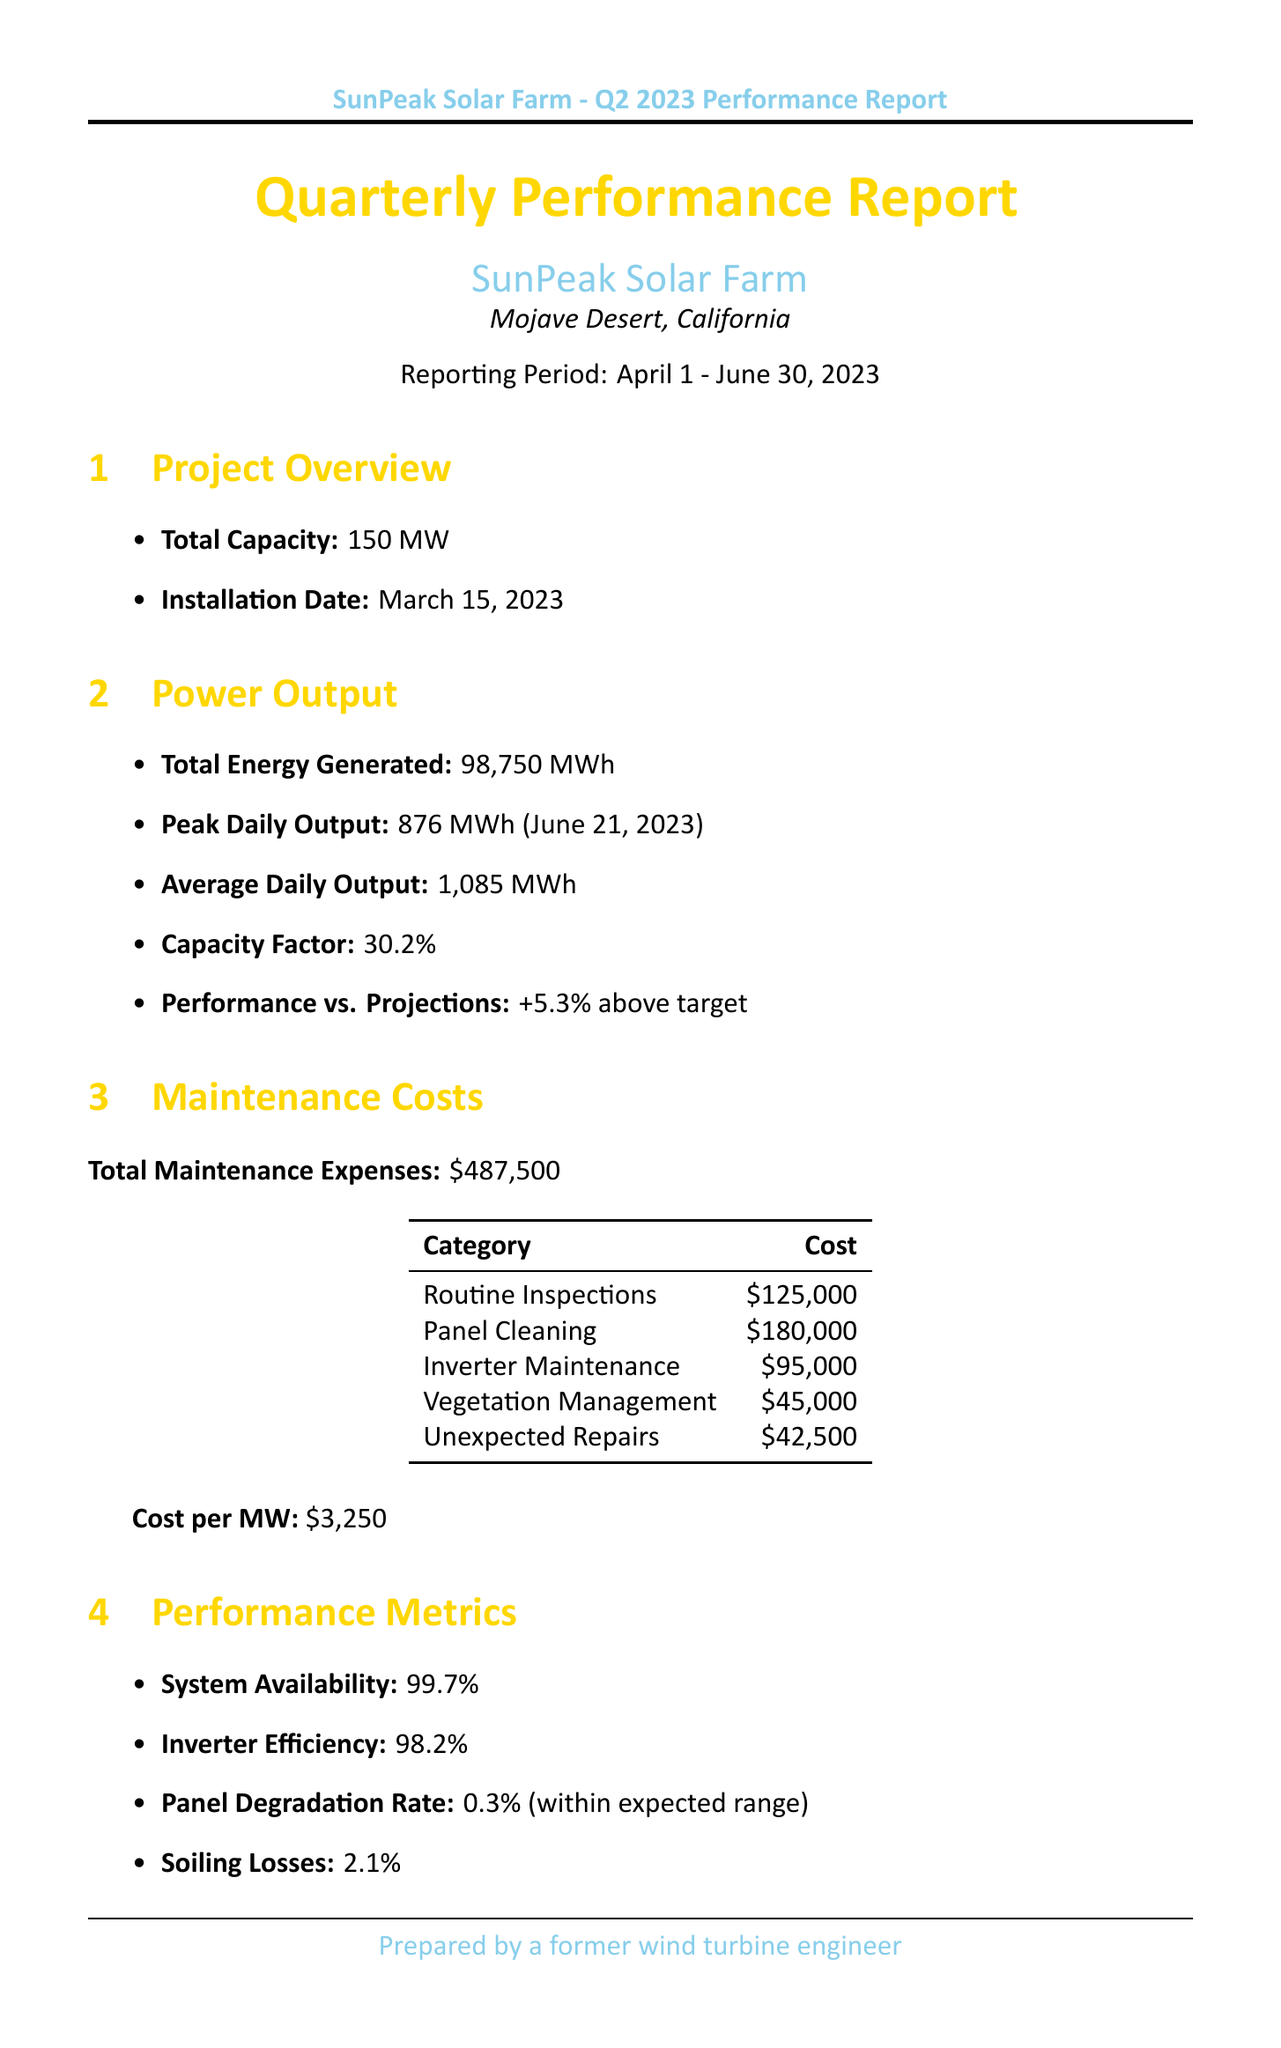What is the project name? The project name is listed in the project overview section of the document.
Answer: SunPeak Solar Farm What is the total energy generated in Q2 2023? The total energy generated can be found in the power output section of the document.
Answer: 98,750 MWh What is the system availability percentage? The system availability percentage is mentioned in the performance metrics section.
Answer: 99.7% What is the total maintenance expense? The total maintenance expense is stated in the maintenance costs section of the report.
Answer: $487,500 What percentage above target is the performance? The performance relative to projections is indicated in the power output section.
Answer: +5.3% How much CO2 emissions were avoided? The amount of CO2 emissions avoided can be found in the environmental impact section.
Answer: 69,125 metric tons What solution was implemented for dust accumulation? The solution for dust accumulation is described in the challenges and solutions section.
Answer: Bi-weekly robotic cleaning system What upgrade is planned for Q4 2023? The planned upgrade is mentioned in the future optimizations section of the document.
Answer: Installation of single-axis trackers How many equivalent trees were planted? The equivalent number of trees planted is listed in the environmental impact section.
Answer: 1,140,000 